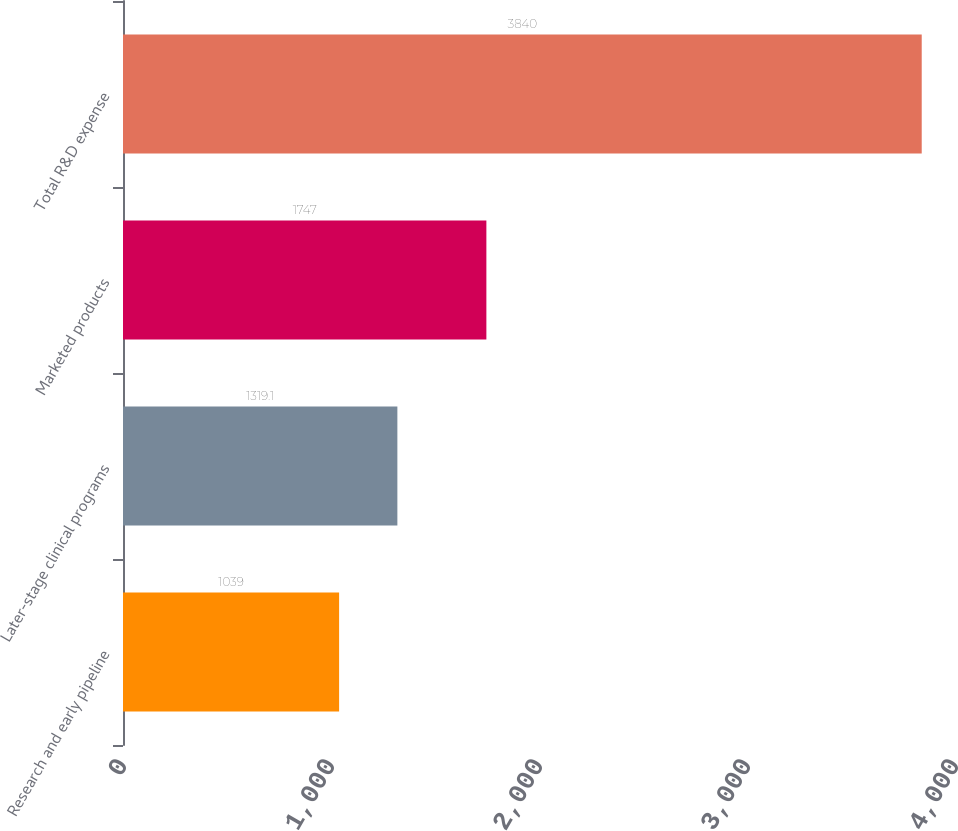Convert chart. <chart><loc_0><loc_0><loc_500><loc_500><bar_chart><fcel>Research and early pipeline<fcel>Later-stage clinical programs<fcel>Marketed products<fcel>Total R&D expense<nl><fcel>1039<fcel>1319.1<fcel>1747<fcel>3840<nl></chart> 